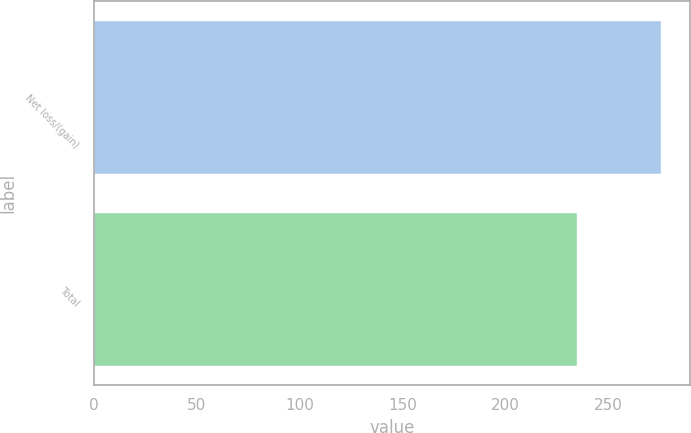Convert chart to OTSL. <chart><loc_0><loc_0><loc_500><loc_500><bar_chart><fcel>Net loss/(gain)<fcel>Total<nl><fcel>276<fcel>235<nl></chart> 